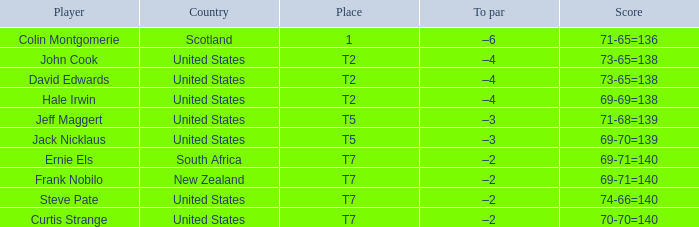Could you parse the entire table? {'header': ['Player', 'Country', 'Place', 'To par', 'Score'], 'rows': [['Colin Montgomerie', 'Scotland', '1', '–6', '71-65=136'], ['John Cook', 'United States', 'T2', '–4', '73-65=138'], ['David Edwards', 'United States', 'T2', '–4', '73-65=138'], ['Hale Irwin', 'United States', 'T2', '–4', '69-69=138'], ['Jeff Maggert', 'United States', 'T5', '–3', '71-68=139'], ['Jack Nicklaus', 'United States', 'T5', '–3', '69-70=139'], ['Ernie Els', 'South Africa', 'T7', '–2', '69-71=140'], ['Frank Nobilo', 'New Zealand', 'T7', '–2', '69-71=140'], ['Steve Pate', 'United States', 'T7', '–2', '74-66=140'], ['Curtis Strange', 'United States', 'T7', '–2', '70-70=140']]} Frank Nobilo plays for what country? New Zealand. 